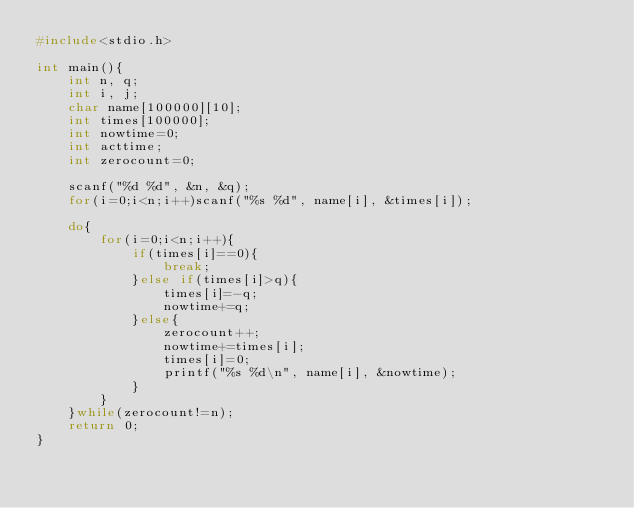Convert code to text. <code><loc_0><loc_0><loc_500><loc_500><_C_>#include<stdio.h>

int main(){
    int n, q;
    int i, j;
    char name[100000][10];
    int times[100000];
    int nowtime=0;
    int acttime;
    int zerocount=0;

    scanf("%d %d", &n, &q);
    for(i=0;i<n;i++)scanf("%s %d", name[i], &times[i]);

    do{
        for(i=0;i<n;i++){
            if(times[i]==0){
                break;
            }else if(times[i]>q){
                times[i]=-q;
                nowtime+=q;
            }else{
                zerocount++;
                nowtime+=times[i];
                times[i]=0;
                printf("%s %d\n", name[i], &nowtime);
            }
        }
    }while(zerocount!=n);
    return 0;
}
</code> 